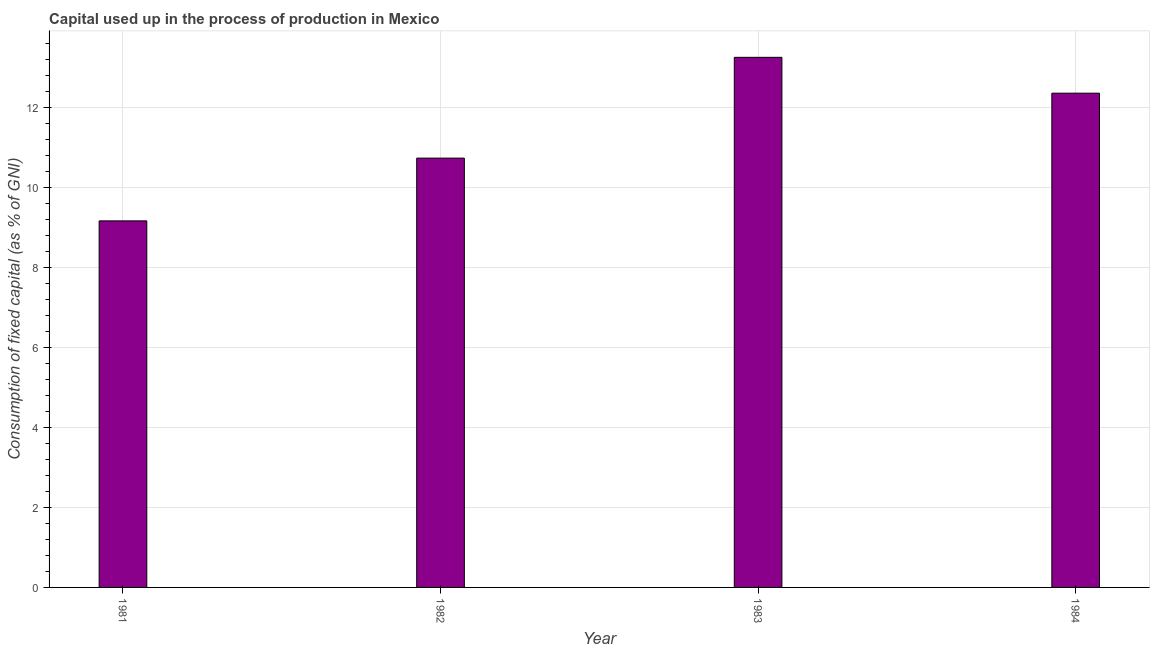Does the graph contain any zero values?
Provide a succinct answer. No. Does the graph contain grids?
Ensure brevity in your answer.  Yes. What is the title of the graph?
Make the answer very short. Capital used up in the process of production in Mexico. What is the label or title of the X-axis?
Your answer should be very brief. Year. What is the label or title of the Y-axis?
Offer a terse response. Consumption of fixed capital (as % of GNI). What is the consumption of fixed capital in 1984?
Ensure brevity in your answer.  12.36. Across all years, what is the maximum consumption of fixed capital?
Provide a short and direct response. 13.26. Across all years, what is the minimum consumption of fixed capital?
Ensure brevity in your answer.  9.17. What is the sum of the consumption of fixed capital?
Provide a short and direct response. 45.52. What is the difference between the consumption of fixed capital in 1982 and 1984?
Your answer should be very brief. -1.62. What is the average consumption of fixed capital per year?
Keep it short and to the point. 11.38. What is the median consumption of fixed capital?
Provide a short and direct response. 11.55. In how many years, is the consumption of fixed capital greater than 10.8 %?
Provide a short and direct response. 2. Do a majority of the years between 1984 and 1983 (inclusive) have consumption of fixed capital greater than 2.4 %?
Your answer should be very brief. No. What is the ratio of the consumption of fixed capital in 1982 to that in 1983?
Provide a succinct answer. 0.81. What is the difference between the highest and the second highest consumption of fixed capital?
Give a very brief answer. 0.9. What is the difference between the highest and the lowest consumption of fixed capital?
Give a very brief answer. 4.09. How many bars are there?
Your response must be concise. 4. Are the values on the major ticks of Y-axis written in scientific E-notation?
Offer a very short reply. No. What is the Consumption of fixed capital (as % of GNI) of 1981?
Your answer should be very brief. 9.17. What is the Consumption of fixed capital (as % of GNI) in 1982?
Offer a terse response. 10.74. What is the Consumption of fixed capital (as % of GNI) of 1983?
Offer a terse response. 13.26. What is the Consumption of fixed capital (as % of GNI) of 1984?
Keep it short and to the point. 12.36. What is the difference between the Consumption of fixed capital (as % of GNI) in 1981 and 1982?
Ensure brevity in your answer.  -1.57. What is the difference between the Consumption of fixed capital (as % of GNI) in 1981 and 1983?
Give a very brief answer. -4.09. What is the difference between the Consumption of fixed capital (as % of GNI) in 1981 and 1984?
Your answer should be compact. -3.19. What is the difference between the Consumption of fixed capital (as % of GNI) in 1982 and 1983?
Keep it short and to the point. -2.52. What is the difference between the Consumption of fixed capital (as % of GNI) in 1982 and 1984?
Provide a short and direct response. -1.62. What is the difference between the Consumption of fixed capital (as % of GNI) in 1983 and 1984?
Give a very brief answer. 0.9. What is the ratio of the Consumption of fixed capital (as % of GNI) in 1981 to that in 1982?
Make the answer very short. 0.85. What is the ratio of the Consumption of fixed capital (as % of GNI) in 1981 to that in 1983?
Give a very brief answer. 0.69. What is the ratio of the Consumption of fixed capital (as % of GNI) in 1981 to that in 1984?
Provide a succinct answer. 0.74. What is the ratio of the Consumption of fixed capital (as % of GNI) in 1982 to that in 1983?
Keep it short and to the point. 0.81. What is the ratio of the Consumption of fixed capital (as % of GNI) in 1982 to that in 1984?
Keep it short and to the point. 0.87. What is the ratio of the Consumption of fixed capital (as % of GNI) in 1983 to that in 1984?
Offer a very short reply. 1.07. 